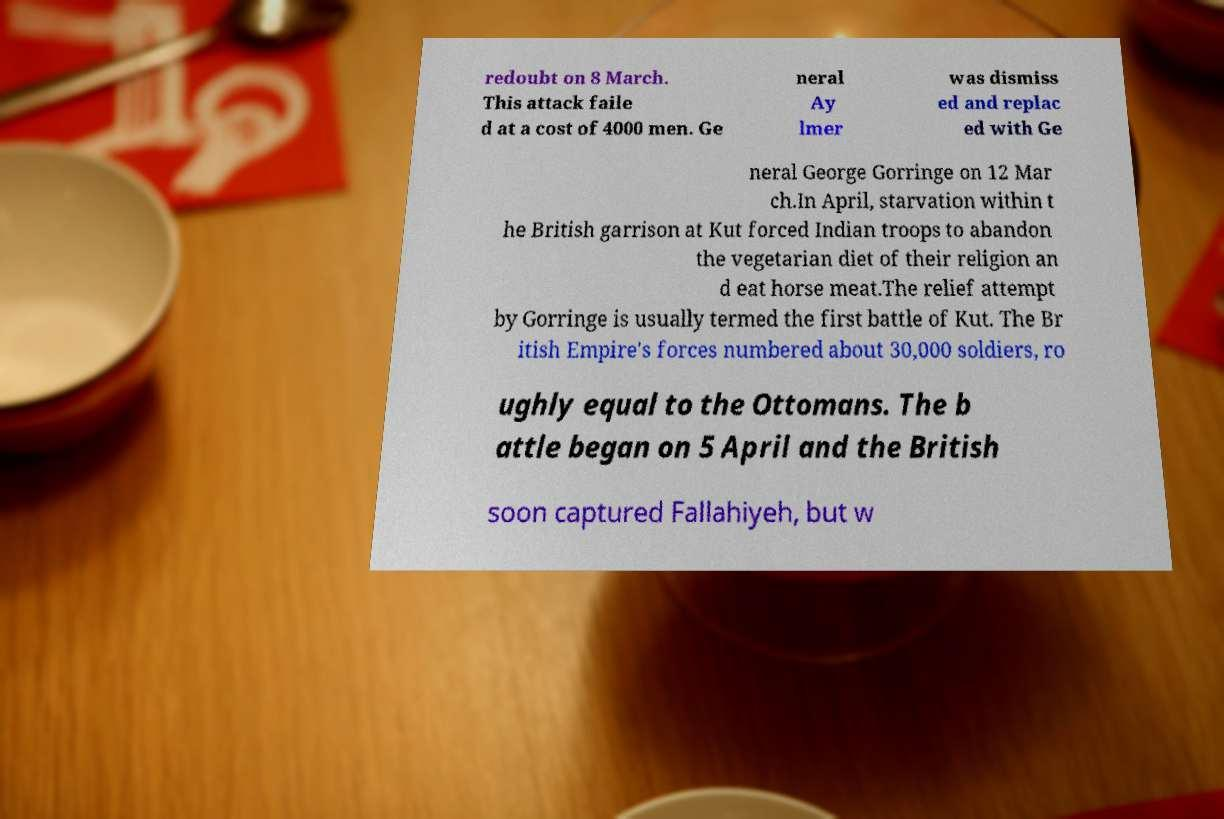Please read and relay the text visible in this image. What does it say? redoubt on 8 March. This attack faile d at a cost of 4000 men. Ge neral Ay lmer was dismiss ed and replac ed with Ge neral George Gorringe on 12 Mar ch.In April, starvation within t he British garrison at Kut forced Indian troops to abandon the vegetarian diet of their religion an d eat horse meat.The relief attempt by Gorringe is usually termed the first battle of Kut. The Br itish Empire's forces numbered about 30,000 soldiers, ro ughly equal to the Ottomans. The b attle began on 5 April and the British soon captured Fallahiyeh, but w 